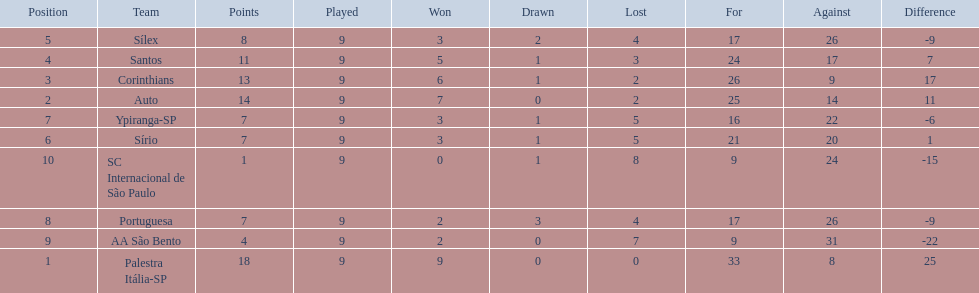How many games did each team play? 9, 9, 9, 9, 9, 9, 9, 9, 9, 9. Did any team score 13 points in the total games they played? 13. What is the name of that team? Corinthians. 